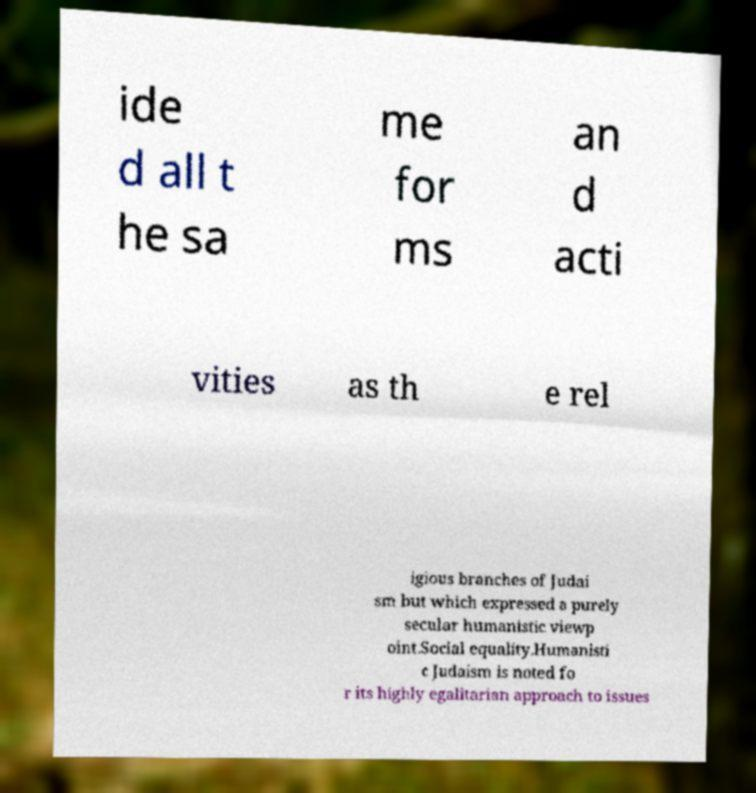Could you extract and type out the text from this image? ide d all t he sa me for ms an d acti vities as th e rel igious branches of Judai sm but which expressed a purely secular humanistic viewp oint.Social equality.Humanisti c Judaism is noted fo r its highly egalitarian approach to issues 